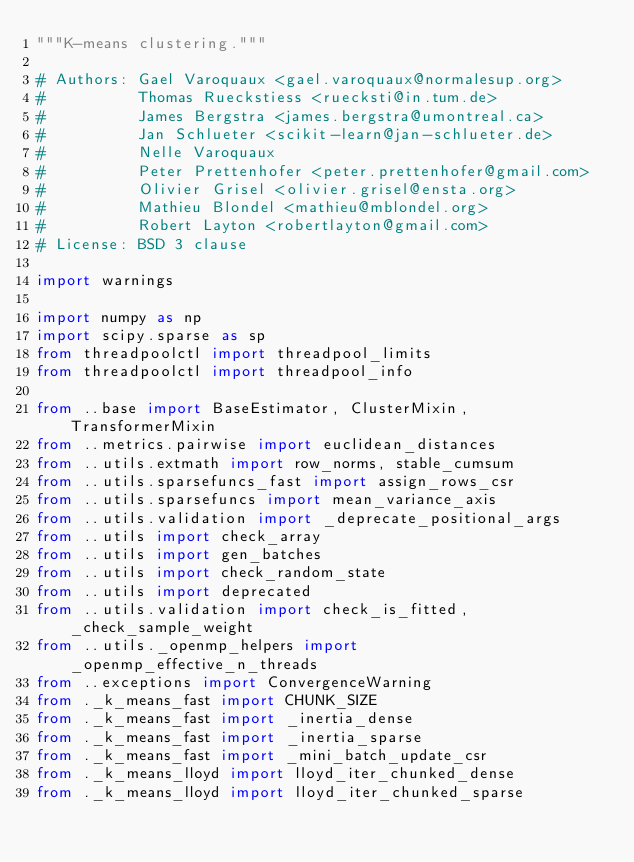Convert code to text. <code><loc_0><loc_0><loc_500><loc_500><_Python_>"""K-means clustering."""

# Authors: Gael Varoquaux <gael.varoquaux@normalesup.org>
#          Thomas Rueckstiess <ruecksti@in.tum.de>
#          James Bergstra <james.bergstra@umontreal.ca>
#          Jan Schlueter <scikit-learn@jan-schlueter.de>
#          Nelle Varoquaux
#          Peter Prettenhofer <peter.prettenhofer@gmail.com>
#          Olivier Grisel <olivier.grisel@ensta.org>
#          Mathieu Blondel <mathieu@mblondel.org>
#          Robert Layton <robertlayton@gmail.com>
# License: BSD 3 clause

import warnings

import numpy as np
import scipy.sparse as sp
from threadpoolctl import threadpool_limits
from threadpoolctl import threadpool_info

from ..base import BaseEstimator, ClusterMixin, TransformerMixin
from ..metrics.pairwise import euclidean_distances
from ..utils.extmath import row_norms, stable_cumsum
from ..utils.sparsefuncs_fast import assign_rows_csr
from ..utils.sparsefuncs import mean_variance_axis
from ..utils.validation import _deprecate_positional_args
from ..utils import check_array
from ..utils import gen_batches
from ..utils import check_random_state
from ..utils import deprecated
from ..utils.validation import check_is_fitted, _check_sample_weight
from ..utils._openmp_helpers import _openmp_effective_n_threads
from ..exceptions import ConvergenceWarning
from ._k_means_fast import CHUNK_SIZE
from ._k_means_fast import _inertia_dense
from ._k_means_fast import _inertia_sparse
from ._k_means_fast import _mini_batch_update_csr
from ._k_means_lloyd import lloyd_iter_chunked_dense
from ._k_means_lloyd import lloyd_iter_chunked_sparse</code> 